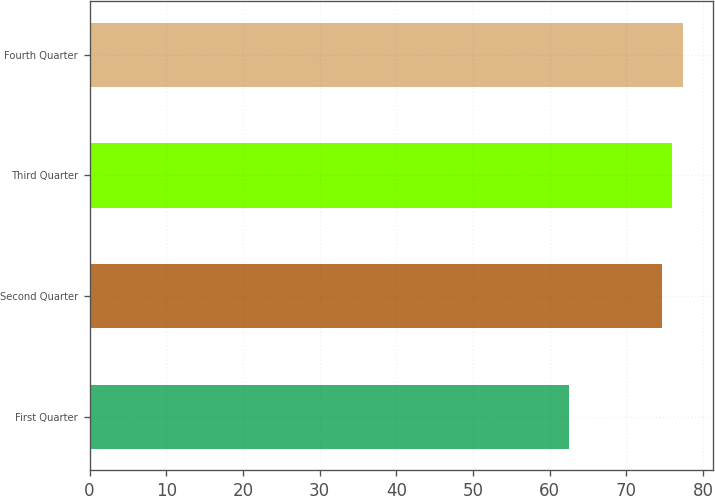Convert chart. <chart><loc_0><loc_0><loc_500><loc_500><bar_chart><fcel>First Quarter<fcel>Second Quarter<fcel>Third Quarter<fcel>Fourth Quarter<nl><fcel>62.5<fcel>74.6<fcel>75.99<fcel>77.38<nl></chart> 